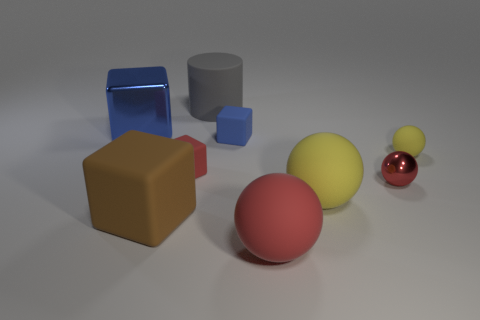Are there any small red spheres made of the same material as the big gray cylinder?
Provide a short and direct response. No. There is a large metal thing that is the same shape as the small blue object; what is its color?
Make the answer very short. Blue. Are the red cube and the yellow thing that is right of the large yellow sphere made of the same material?
Offer a very short reply. Yes. What is the shape of the big thing behind the large blue shiny block on the left side of the metal ball?
Provide a succinct answer. Cylinder. Is the size of the blue thing that is left of the blue matte cube the same as the large gray thing?
Your response must be concise. Yes. What number of other things are there of the same shape as the big metallic object?
Give a very brief answer. 3. There is a matte sphere that is in front of the brown thing; is it the same color as the large shiny block?
Provide a short and direct response. No. Are there any matte cubes of the same color as the small shiny object?
Provide a short and direct response. Yes. What number of small rubber objects are right of the big red matte thing?
Your answer should be very brief. 1. How many other things are the same size as the shiny block?
Ensure brevity in your answer.  4. 